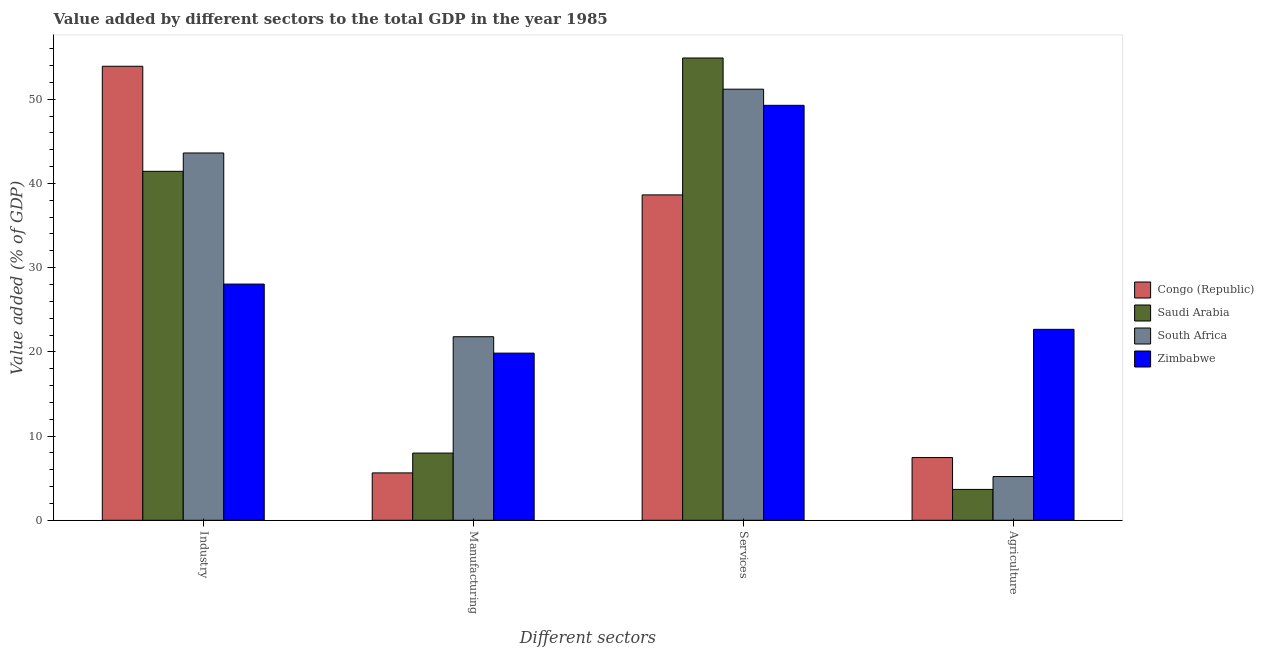What is the label of the 2nd group of bars from the left?
Offer a very short reply. Manufacturing. What is the value added by agricultural sector in South Africa?
Make the answer very short. 5.19. Across all countries, what is the maximum value added by manufacturing sector?
Offer a terse response. 21.8. Across all countries, what is the minimum value added by manufacturing sector?
Your answer should be compact. 5.62. In which country was the value added by manufacturing sector maximum?
Give a very brief answer. South Africa. In which country was the value added by manufacturing sector minimum?
Keep it short and to the point. Congo (Republic). What is the total value added by services sector in the graph?
Your answer should be very brief. 194.01. What is the difference between the value added by industrial sector in South Africa and that in Congo (Republic)?
Make the answer very short. -10.3. What is the difference between the value added by agricultural sector in South Africa and the value added by industrial sector in Zimbabwe?
Ensure brevity in your answer.  -22.86. What is the average value added by services sector per country?
Provide a succinct answer. 48.5. What is the difference between the value added by services sector and value added by industrial sector in Zimbabwe?
Offer a terse response. 21.23. What is the ratio of the value added by manufacturing sector in Zimbabwe to that in Saudi Arabia?
Your response must be concise. 2.49. What is the difference between the highest and the second highest value added by industrial sector?
Your answer should be very brief. 10.3. What is the difference between the highest and the lowest value added by services sector?
Offer a terse response. 16.26. What does the 2nd bar from the left in Services represents?
Provide a succinct answer. Saudi Arabia. What does the 3rd bar from the right in Agriculture represents?
Offer a terse response. Saudi Arabia. Is it the case that in every country, the sum of the value added by industrial sector and value added by manufacturing sector is greater than the value added by services sector?
Provide a succinct answer. No. How many bars are there?
Your answer should be very brief. 16. What is the difference between two consecutive major ticks on the Y-axis?
Your answer should be very brief. 10. Does the graph contain any zero values?
Offer a very short reply. No. Does the graph contain grids?
Your answer should be compact. No. Where does the legend appear in the graph?
Provide a short and direct response. Center right. How many legend labels are there?
Your response must be concise. 4. What is the title of the graph?
Offer a terse response. Value added by different sectors to the total GDP in the year 1985. Does "Tonga" appear as one of the legend labels in the graph?
Your answer should be very brief. No. What is the label or title of the X-axis?
Give a very brief answer. Different sectors. What is the label or title of the Y-axis?
Your answer should be compact. Value added (% of GDP). What is the Value added (% of GDP) in Congo (Republic) in Industry?
Give a very brief answer. 53.91. What is the Value added (% of GDP) in Saudi Arabia in Industry?
Keep it short and to the point. 41.44. What is the Value added (% of GDP) of South Africa in Industry?
Offer a very short reply. 43.62. What is the Value added (% of GDP) in Zimbabwe in Industry?
Give a very brief answer. 28.05. What is the Value added (% of GDP) of Congo (Republic) in Manufacturing?
Give a very brief answer. 5.62. What is the Value added (% of GDP) in Saudi Arabia in Manufacturing?
Your response must be concise. 7.98. What is the Value added (% of GDP) in South Africa in Manufacturing?
Offer a very short reply. 21.8. What is the Value added (% of GDP) in Zimbabwe in Manufacturing?
Keep it short and to the point. 19.85. What is the Value added (% of GDP) in Congo (Republic) in Services?
Ensure brevity in your answer.  38.64. What is the Value added (% of GDP) in Saudi Arabia in Services?
Provide a succinct answer. 54.9. What is the Value added (% of GDP) of South Africa in Services?
Make the answer very short. 51.19. What is the Value added (% of GDP) in Zimbabwe in Services?
Offer a very short reply. 49.28. What is the Value added (% of GDP) of Congo (Republic) in Agriculture?
Provide a short and direct response. 7.45. What is the Value added (% of GDP) in Saudi Arabia in Agriculture?
Provide a short and direct response. 3.66. What is the Value added (% of GDP) in South Africa in Agriculture?
Give a very brief answer. 5.19. What is the Value added (% of GDP) of Zimbabwe in Agriculture?
Keep it short and to the point. 22.67. Across all Different sectors, what is the maximum Value added (% of GDP) in Congo (Republic)?
Offer a terse response. 53.91. Across all Different sectors, what is the maximum Value added (% of GDP) of Saudi Arabia?
Provide a succinct answer. 54.9. Across all Different sectors, what is the maximum Value added (% of GDP) in South Africa?
Your answer should be compact. 51.19. Across all Different sectors, what is the maximum Value added (% of GDP) in Zimbabwe?
Make the answer very short. 49.28. Across all Different sectors, what is the minimum Value added (% of GDP) in Congo (Republic)?
Ensure brevity in your answer.  5.62. Across all Different sectors, what is the minimum Value added (% of GDP) in Saudi Arabia?
Give a very brief answer. 3.66. Across all Different sectors, what is the minimum Value added (% of GDP) of South Africa?
Offer a terse response. 5.19. Across all Different sectors, what is the minimum Value added (% of GDP) of Zimbabwe?
Provide a succinct answer. 19.85. What is the total Value added (% of GDP) in Congo (Republic) in the graph?
Offer a very short reply. 105.62. What is the total Value added (% of GDP) in Saudi Arabia in the graph?
Provide a short and direct response. 107.98. What is the total Value added (% of GDP) in South Africa in the graph?
Make the answer very short. 121.8. What is the total Value added (% of GDP) in Zimbabwe in the graph?
Offer a very short reply. 119.85. What is the difference between the Value added (% of GDP) of Congo (Republic) in Industry and that in Manufacturing?
Your response must be concise. 48.29. What is the difference between the Value added (% of GDP) in Saudi Arabia in Industry and that in Manufacturing?
Provide a succinct answer. 33.46. What is the difference between the Value added (% of GDP) in South Africa in Industry and that in Manufacturing?
Offer a very short reply. 21.82. What is the difference between the Value added (% of GDP) of Zimbabwe in Industry and that in Manufacturing?
Offer a very short reply. 8.2. What is the difference between the Value added (% of GDP) of Congo (Republic) in Industry and that in Services?
Ensure brevity in your answer.  15.28. What is the difference between the Value added (% of GDP) of Saudi Arabia in Industry and that in Services?
Your answer should be very brief. -13.46. What is the difference between the Value added (% of GDP) of South Africa in Industry and that in Services?
Give a very brief answer. -7.58. What is the difference between the Value added (% of GDP) of Zimbabwe in Industry and that in Services?
Make the answer very short. -21.23. What is the difference between the Value added (% of GDP) in Congo (Republic) in Industry and that in Agriculture?
Provide a short and direct response. 46.47. What is the difference between the Value added (% of GDP) of Saudi Arabia in Industry and that in Agriculture?
Give a very brief answer. 37.77. What is the difference between the Value added (% of GDP) in South Africa in Industry and that in Agriculture?
Provide a succinct answer. 38.43. What is the difference between the Value added (% of GDP) in Zimbabwe in Industry and that in Agriculture?
Your answer should be compact. 5.38. What is the difference between the Value added (% of GDP) of Congo (Republic) in Manufacturing and that in Services?
Offer a very short reply. -33.01. What is the difference between the Value added (% of GDP) in Saudi Arabia in Manufacturing and that in Services?
Make the answer very short. -46.92. What is the difference between the Value added (% of GDP) in South Africa in Manufacturing and that in Services?
Your answer should be compact. -29.4. What is the difference between the Value added (% of GDP) in Zimbabwe in Manufacturing and that in Services?
Your response must be concise. -29.43. What is the difference between the Value added (% of GDP) in Congo (Republic) in Manufacturing and that in Agriculture?
Provide a short and direct response. -1.82. What is the difference between the Value added (% of GDP) of Saudi Arabia in Manufacturing and that in Agriculture?
Give a very brief answer. 4.32. What is the difference between the Value added (% of GDP) in South Africa in Manufacturing and that in Agriculture?
Your answer should be very brief. 16.61. What is the difference between the Value added (% of GDP) of Zimbabwe in Manufacturing and that in Agriculture?
Offer a very short reply. -2.82. What is the difference between the Value added (% of GDP) of Congo (Republic) in Services and that in Agriculture?
Provide a short and direct response. 31.19. What is the difference between the Value added (% of GDP) in Saudi Arabia in Services and that in Agriculture?
Give a very brief answer. 51.23. What is the difference between the Value added (% of GDP) in South Africa in Services and that in Agriculture?
Your answer should be very brief. 46. What is the difference between the Value added (% of GDP) in Zimbabwe in Services and that in Agriculture?
Ensure brevity in your answer.  26.6. What is the difference between the Value added (% of GDP) in Congo (Republic) in Industry and the Value added (% of GDP) in Saudi Arabia in Manufacturing?
Your answer should be compact. 45.93. What is the difference between the Value added (% of GDP) of Congo (Republic) in Industry and the Value added (% of GDP) of South Africa in Manufacturing?
Provide a succinct answer. 32.12. What is the difference between the Value added (% of GDP) of Congo (Republic) in Industry and the Value added (% of GDP) of Zimbabwe in Manufacturing?
Make the answer very short. 34.06. What is the difference between the Value added (% of GDP) in Saudi Arabia in Industry and the Value added (% of GDP) in South Africa in Manufacturing?
Give a very brief answer. 19.64. What is the difference between the Value added (% of GDP) of Saudi Arabia in Industry and the Value added (% of GDP) of Zimbabwe in Manufacturing?
Offer a very short reply. 21.59. What is the difference between the Value added (% of GDP) in South Africa in Industry and the Value added (% of GDP) in Zimbabwe in Manufacturing?
Offer a terse response. 23.77. What is the difference between the Value added (% of GDP) in Congo (Republic) in Industry and the Value added (% of GDP) in Saudi Arabia in Services?
Give a very brief answer. -0.98. What is the difference between the Value added (% of GDP) in Congo (Republic) in Industry and the Value added (% of GDP) in South Africa in Services?
Provide a short and direct response. 2.72. What is the difference between the Value added (% of GDP) in Congo (Republic) in Industry and the Value added (% of GDP) in Zimbabwe in Services?
Your answer should be compact. 4.64. What is the difference between the Value added (% of GDP) of Saudi Arabia in Industry and the Value added (% of GDP) of South Africa in Services?
Make the answer very short. -9.75. What is the difference between the Value added (% of GDP) of Saudi Arabia in Industry and the Value added (% of GDP) of Zimbabwe in Services?
Provide a short and direct response. -7.84. What is the difference between the Value added (% of GDP) in South Africa in Industry and the Value added (% of GDP) in Zimbabwe in Services?
Offer a terse response. -5.66. What is the difference between the Value added (% of GDP) of Congo (Republic) in Industry and the Value added (% of GDP) of Saudi Arabia in Agriculture?
Provide a succinct answer. 50.25. What is the difference between the Value added (% of GDP) of Congo (Republic) in Industry and the Value added (% of GDP) of South Africa in Agriculture?
Give a very brief answer. 48.72. What is the difference between the Value added (% of GDP) in Congo (Republic) in Industry and the Value added (% of GDP) in Zimbabwe in Agriculture?
Your answer should be compact. 31.24. What is the difference between the Value added (% of GDP) of Saudi Arabia in Industry and the Value added (% of GDP) of South Africa in Agriculture?
Provide a succinct answer. 36.25. What is the difference between the Value added (% of GDP) of Saudi Arabia in Industry and the Value added (% of GDP) of Zimbabwe in Agriculture?
Provide a succinct answer. 18.77. What is the difference between the Value added (% of GDP) of South Africa in Industry and the Value added (% of GDP) of Zimbabwe in Agriculture?
Provide a succinct answer. 20.94. What is the difference between the Value added (% of GDP) of Congo (Republic) in Manufacturing and the Value added (% of GDP) of Saudi Arabia in Services?
Ensure brevity in your answer.  -49.27. What is the difference between the Value added (% of GDP) of Congo (Republic) in Manufacturing and the Value added (% of GDP) of South Africa in Services?
Ensure brevity in your answer.  -45.57. What is the difference between the Value added (% of GDP) in Congo (Republic) in Manufacturing and the Value added (% of GDP) in Zimbabwe in Services?
Offer a very short reply. -43.65. What is the difference between the Value added (% of GDP) of Saudi Arabia in Manufacturing and the Value added (% of GDP) of South Africa in Services?
Your answer should be compact. -43.21. What is the difference between the Value added (% of GDP) in Saudi Arabia in Manufacturing and the Value added (% of GDP) in Zimbabwe in Services?
Ensure brevity in your answer.  -41.3. What is the difference between the Value added (% of GDP) in South Africa in Manufacturing and the Value added (% of GDP) in Zimbabwe in Services?
Offer a terse response. -27.48. What is the difference between the Value added (% of GDP) in Congo (Republic) in Manufacturing and the Value added (% of GDP) in Saudi Arabia in Agriculture?
Give a very brief answer. 1.96. What is the difference between the Value added (% of GDP) of Congo (Republic) in Manufacturing and the Value added (% of GDP) of South Africa in Agriculture?
Make the answer very short. 0.43. What is the difference between the Value added (% of GDP) of Congo (Republic) in Manufacturing and the Value added (% of GDP) of Zimbabwe in Agriculture?
Your answer should be very brief. -17.05. What is the difference between the Value added (% of GDP) in Saudi Arabia in Manufacturing and the Value added (% of GDP) in South Africa in Agriculture?
Your response must be concise. 2.79. What is the difference between the Value added (% of GDP) of Saudi Arabia in Manufacturing and the Value added (% of GDP) of Zimbabwe in Agriculture?
Provide a short and direct response. -14.69. What is the difference between the Value added (% of GDP) of South Africa in Manufacturing and the Value added (% of GDP) of Zimbabwe in Agriculture?
Your answer should be very brief. -0.88. What is the difference between the Value added (% of GDP) of Congo (Republic) in Services and the Value added (% of GDP) of Saudi Arabia in Agriculture?
Offer a terse response. 34.97. What is the difference between the Value added (% of GDP) of Congo (Republic) in Services and the Value added (% of GDP) of South Africa in Agriculture?
Offer a terse response. 33.45. What is the difference between the Value added (% of GDP) of Congo (Republic) in Services and the Value added (% of GDP) of Zimbabwe in Agriculture?
Your answer should be compact. 15.96. What is the difference between the Value added (% of GDP) in Saudi Arabia in Services and the Value added (% of GDP) in South Africa in Agriculture?
Provide a short and direct response. 49.71. What is the difference between the Value added (% of GDP) of Saudi Arabia in Services and the Value added (% of GDP) of Zimbabwe in Agriculture?
Provide a succinct answer. 32.22. What is the difference between the Value added (% of GDP) in South Africa in Services and the Value added (% of GDP) in Zimbabwe in Agriculture?
Your response must be concise. 28.52. What is the average Value added (% of GDP) in Congo (Republic) per Different sectors?
Your response must be concise. 26.41. What is the average Value added (% of GDP) in Saudi Arabia per Different sectors?
Your answer should be compact. 26.99. What is the average Value added (% of GDP) in South Africa per Different sectors?
Make the answer very short. 30.45. What is the average Value added (% of GDP) of Zimbabwe per Different sectors?
Provide a short and direct response. 29.96. What is the difference between the Value added (% of GDP) of Congo (Republic) and Value added (% of GDP) of Saudi Arabia in Industry?
Your response must be concise. 12.48. What is the difference between the Value added (% of GDP) in Congo (Republic) and Value added (% of GDP) in South Africa in Industry?
Provide a succinct answer. 10.3. What is the difference between the Value added (% of GDP) of Congo (Republic) and Value added (% of GDP) of Zimbabwe in Industry?
Keep it short and to the point. 25.86. What is the difference between the Value added (% of GDP) of Saudi Arabia and Value added (% of GDP) of South Africa in Industry?
Keep it short and to the point. -2.18. What is the difference between the Value added (% of GDP) of Saudi Arabia and Value added (% of GDP) of Zimbabwe in Industry?
Make the answer very short. 13.39. What is the difference between the Value added (% of GDP) of South Africa and Value added (% of GDP) of Zimbabwe in Industry?
Offer a terse response. 15.57. What is the difference between the Value added (% of GDP) in Congo (Republic) and Value added (% of GDP) in Saudi Arabia in Manufacturing?
Give a very brief answer. -2.36. What is the difference between the Value added (% of GDP) in Congo (Republic) and Value added (% of GDP) in South Africa in Manufacturing?
Make the answer very short. -16.17. What is the difference between the Value added (% of GDP) in Congo (Republic) and Value added (% of GDP) in Zimbabwe in Manufacturing?
Make the answer very short. -14.23. What is the difference between the Value added (% of GDP) of Saudi Arabia and Value added (% of GDP) of South Africa in Manufacturing?
Your answer should be very brief. -13.82. What is the difference between the Value added (% of GDP) of Saudi Arabia and Value added (% of GDP) of Zimbabwe in Manufacturing?
Your answer should be compact. -11.87. What is the difference between the Value added (% of GDP) of South Africa and Value added (% of GDP) of Zimbabwe in Manufacturing?
Your response must be concise. 1.95. What is the difference between the Value added (% of GDP) of Congo (Republic) and Value added (% of GDP) of Saudi Arabia in Services?
Your response must be concise. -16.26. What is the difference between the Value added (% of GDP) of Congo (Republic) and Value added (% of GDP) of South Africa in Services?
Your response must be concise. -12.55. What is the difference between the Value added (% of GDP) in Congo (Republic) and Value added (% of GDP) in Zimbabwe in Services?
Make the answer very short. -10.64. What is the difference between the Value added (% of GDP) of Saudi Arabia and Value added (% of GDP) of South Africa in Services?
Ensure brevity in your answer.  3.7. What is the difference between the Value added (% of GDP) of Saudi Arabia and Value added (% of GDP) of Zimbabwe in Services?
Keep it short and to the point. 5.62. What is the difference between the Value added (% of GDP) in South Africa and Value added (% of GDP) in Zimbabwe in Services?
Provide a short and direct response. 1.92. What is the difference between the Value added (% of GDP) of Congo (Republic) and Value added (% of GDP) of Saudi Arabia in Agriculture?
Make the answer very short. 3.78. What is the difference between the Value added (% of GDP) in Congo (Republic) and Value added (% of GDP) in South Africa in Agriculture?
Provide a succinct answer. 2.26. What is the difference between the Value added (% of GDP) of Congo (Republic) and Value added (% of GDP) of Zimbabwe in Agriculture?
Make the answer very short. -15.23. What is the difference between the Value added (% of GDP) of Saudi Arabia and Value added (% of GDP) of South Africa in Agriculture?
Offer a terse response. -1.53. What is the difference between the Value added (% of GDP) in Saudi Arabia and Value added (% of GDP) in Zimbabwe in Agriculture?
Offer a very short reply. -19.01. What is the difference between the Value added (% of GDP) in South Africa and Value added (% of GDP) in Zimbabwe in Agriculture?
Provide a short and direct response. -17.48. What is the ratio of the Value added (% of GDP) in Congo (Republic) in Industry to that in Manufacturing?
Your response must be concise. 9.59. What is the ratio of the Value added (% of GDP) of Saudi Arabia in Industry to that in Manufacturing?
Give a very brief answer. 5.19. What is the ratio of the Value added (% of GDP) of South Africa in Industry to that in Manufacturing?
Make the answer very short. 2. What is the ratio of the Value added (% of GDP) of Zimbabwe in Industry to that in Manufacturing?
Make the answer very short. 1.41. What is the ratio of the Value added (% of GDP) in Congo (Republic) in Industry to that in Services?
Keep it short and to the point. 1.4. What is the ratio of the Value added (% of GDP) in Saudi Arabia in Industry to that in Services?
Provide a succinct answer. 0.75. What is the ratio of the Value added (% of GDP) in South Africa in Industry to that in Services?
Your response must be concise. 0.85. What is the ratio of the Value added (% of GDP) of Zimbabwe in Industry to that in Services?
Your answer should be compact. 0.57. What is the ratio of the Value added (% of GDP) of Congo (Republic) in Industry to that in Agriculture?
Keep it short and to the point. 7.24. What is the ratio of the Value added (% of GDP) in Saudi Arabia in Industry to that in Agriculture?
Your answer should be compact. 11.31. What is the ratio of the Value added (% of GDP) of South Africa in Industry to that in Agriculture?
Offer a terse response. 8.4. What is the ratio of the Value added (% of GDP) in Zimbabwe in Industry to that in Agriculture?
Offer a very short reply. 1.24. What is the ratio of the Value added (% of GDP) of Congo (Republic) in Manufacturing to that in Services?
Offer a terse response. 0.15. What is the ratio of the Value added (% of GDP) in Saudi Arabia in Manufacturing to that in Services?
Provide a short and direct response. 0.15. What is the ratio of the Value added (% of GDP) in South Africa in Manufacturing to that in Services?
Your response must be concise. 0.43. What is the ratio of the Value added (% of GDP) of Zimbabwe in Manufacturing to that in Services?
Provide a succinct answer. 0.4. What is the ratio of the Value added (% of GDP) in Congo (Republic) in Manufacturing to that in Agriculture?
Keep it short and to the point. 0.76. What is the ratio of the Value added (% of GDP) in Saudi Arabia in Manufacturing to that in Agriculture?
Provide a succinct answer. 2.18. What is the ratio of the Value added (% of GDP) of South Africa in Manufacturing to that in Agriculture?
Your answer should be very brief. 4.2. What is the ratio of the Value added (% of GDP) in Zimbabwe in Manufacturing to that in Agriculture?
Provide a short and direct response. 0.88. What is the ratio of the Value added (% of GDP) in Congo (Republic) in Services to that in Agriculture?
Keep it short and to the point. 5.19. What is the ratio of the Value added (% of GDP) in Saudi Arabia in Services to that in Agriculture?
Ensure brevity in your answer.  14.98. What is the ratio of the Value added (% of GDP) of South Africa in Services to that in Agriculture?
Your response must be concise. 9.86. What is the ratio of the Value added (% of GDP) of Zimbabwe in Services to that in Agriculture?
Give a very brief answer. 2.17. What is the difference between the highest and the second highest Value added (% of GDP) of Congo (Republic)?
Offer a terse response. 15.28. What is the difference between the highest and the second highest Value added (% of GDP) of Saudi Arabia?
Give a very brief answer. 13.46. What is the difference between the highest and the second highest Value added (% of GDP) of South Africa?
Provide a succinct answer. 7.58. What is the difference between the highest and the second highest Value added (% of GDP) in Zimbabwe?
Offer a terse response. 21.23. What is the difference between the highest and the lowest Value added (% of GDP) of Congo (Republic)?
Your answer should be very brief. 48.29. What is the difference between the highest and the lowest Value added (% of GDP) of Saudi Arabia?
Your answer should be compact. 51.23. What is the difference between the highest and the lowest Value added (% of GDP) of South Africa?
Your answer should be very brief. 46. What is the difference between the highest and the lowest Value added (% of GDP) of Zimbabwe?
Ensure brevity in your answer.  29.43. 